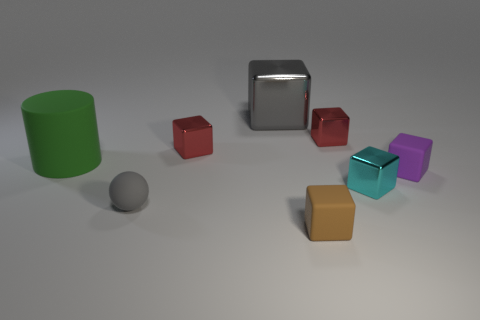Subtract all gray blocks. How many blocks are left? 5 Subtract all big gray blocks. How many blocks are left? 5 Subtract all yellow blocks. Subtract all purple cylinders. How many blocks are left? 6 Add 1 cyan matte balls. How many objects exist? 9 Subtract all spheres. How many objects are left? 7 Subtract 0 yellow cubes. How many objects are left? 8 Subtract all tiny green shiny balls. Subtract all tiny cyan objects. How many objects are left? 7 Add 6 spheres. How many spheres are left? 7 Add 8 green rubber things. How many green rubber things exist? 9 